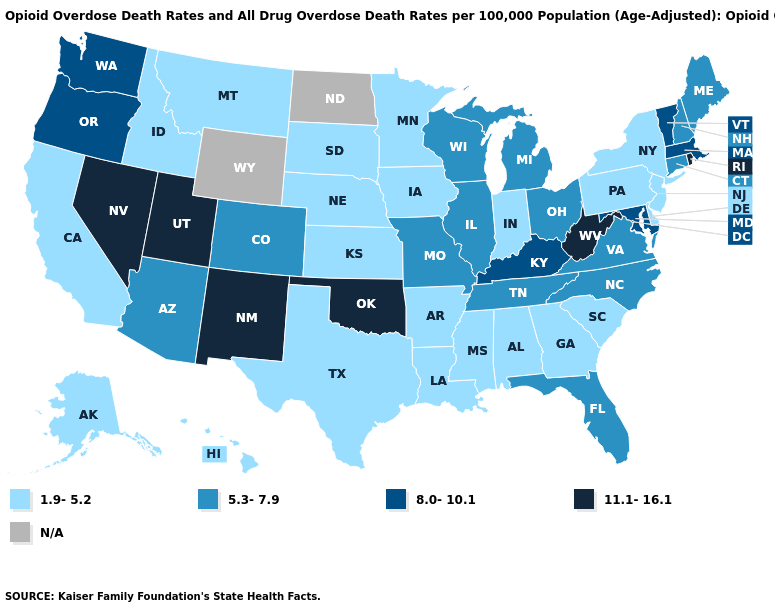Name the states that have a value in the range N/A?
Short answer required. North Dakota, Wyoming. Which states hav the highest value in the MidWest?
Write a very short answer. Illinois, Michigan, Missouri, Ohio, Wisconsin. Name the states that have a value in the range 5.3-7.9?
Write a very short answer. Arizona, Colorado, Connecticut, Florida, Illinois, Maine, Michigan, Missouri, New Hampshire, North Carolina, Ohio, Tennessee, Virginia, Wisconsin. What is the lowest value in the South?
Concise answer only. 1.9-5.2. Which states have the lowest value in the West?
Short answer required. Alaska, California, Hawaii, Idaho, Montana. Name the states that have a value in the range 11.1-16.1?
Be succinct. Nevada, New Mexico, Oklahoma, Rhode Island, Utah, West Virginia. Name the states that have a value in the range 11.1-16.1?
Keep it brief. Nevada, New Mexico, Oklahoma, Rhode Island, Utah, West Virginia. Does the map have missing data?
Write a very short answer. Yes. Which states have the lowest value in the USA?
Answer briefly. Alabama, Alaska, Arkansas, California, Delaware, Georgia, Hawaii, Idaho, Indiana, Iowa, Kansas, Louisiana, Minnesota, Mississippi, Montana, Nebraska, New Jersey, New York, Pennsylvania, South Carolina, South Dakota, Texas. Which states hav the highest value in the South?
Concise answer only. Oklahoma, West Virginia. Among the states that border Florida , which have the highest value?
Answer briefly. Alabama, Georgia. Which states hav the highest value in the South?
Concise answer only. Oklahoma, West Virginia. What is the value of New Jersey?
Concise answer only. 1.9-5.2. How many symbols are there in the legend?
Answer briefly. 5. 